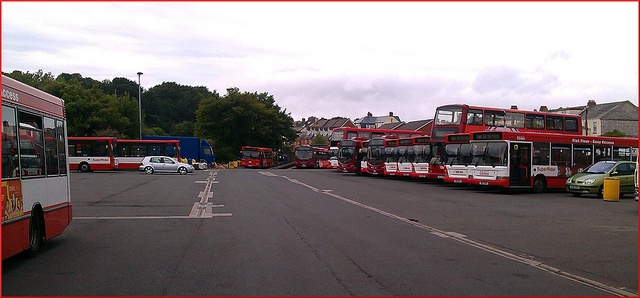Describe the objects in this image and their specific colors. I can see bus in red, black, maroon, and gray tones, bus in red, black, maroon, gray, and darkgray tones, bus in red, black, gray, maroon, and brown tones, bus in red, gray, black, maroon, and brown tones, and car in red, black, gray, darkgray, and darkgreen tones in this image. 